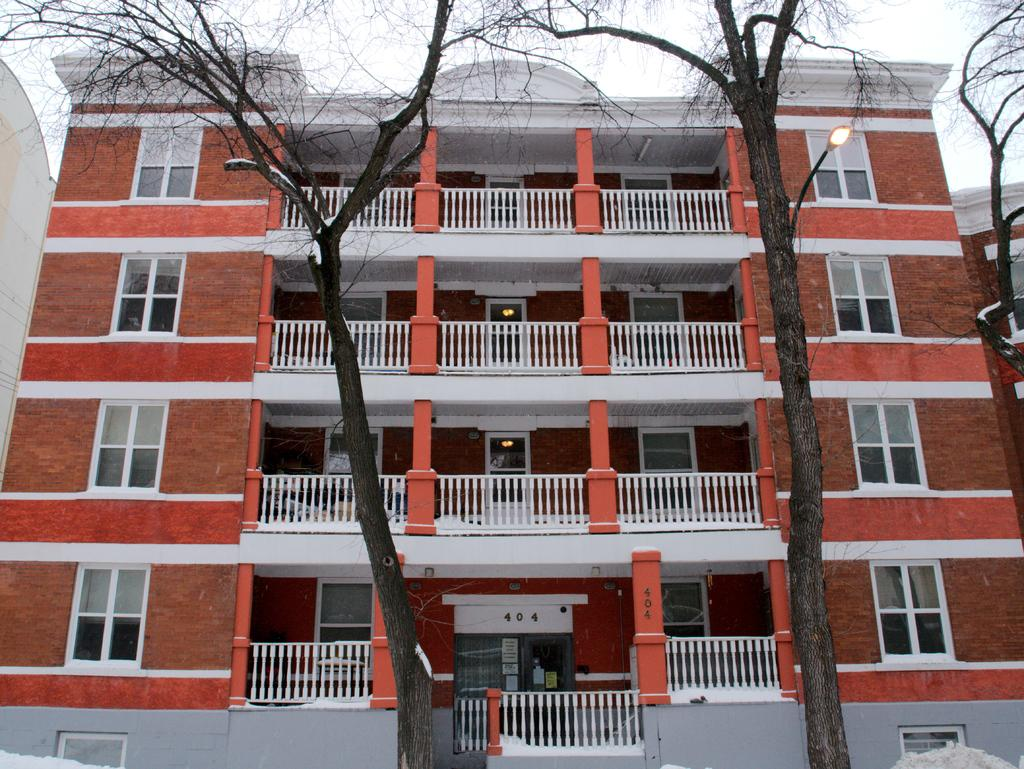What type of natural elements can be seen in the image? There are trees in the image. What type of man-made structures can be seen in the image? There are street lights, at least one building, windows, railings, doors, and a wall in the image. What is visible in the sky in the image? The sky is visible in the image. How many objects can be seen in the image? There are objects in the image. What type of suit is the sheep wearing in the image? There is no sheep or suit present in the image. What game is being played in the image? There is no game being played in the image. 